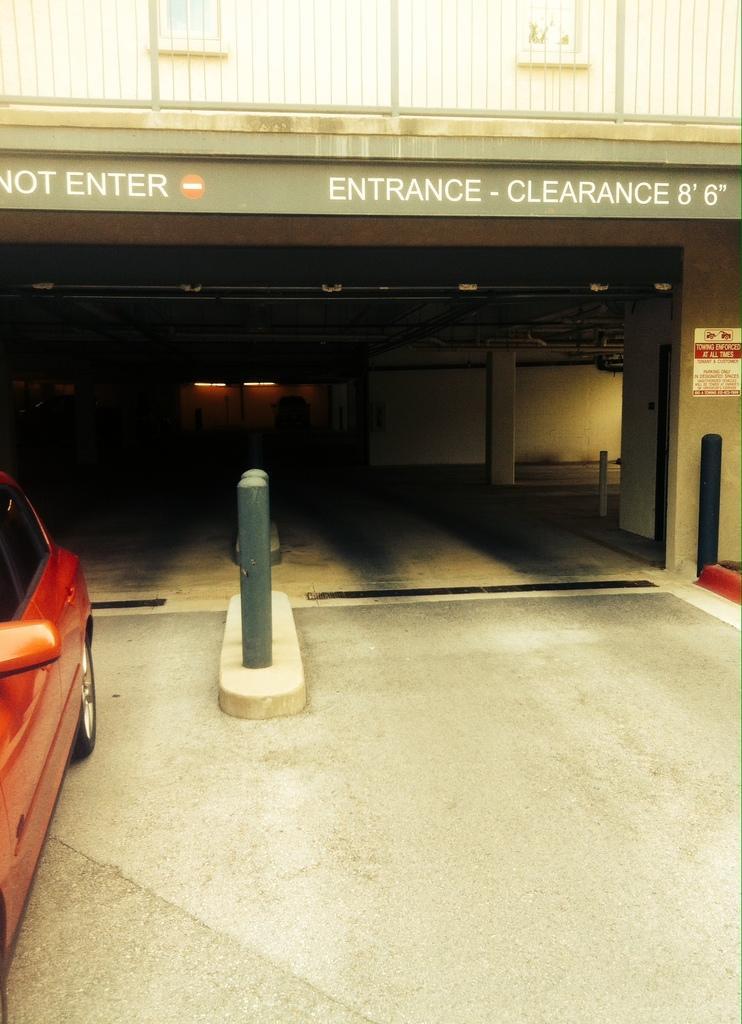Could you give a brief overview of what you see in this image? In this picture we can see a car on the left side. There are a few poles. We can see a poster on the wall. There is a text visible on a building. We can see lights and a vehicle in the background. 